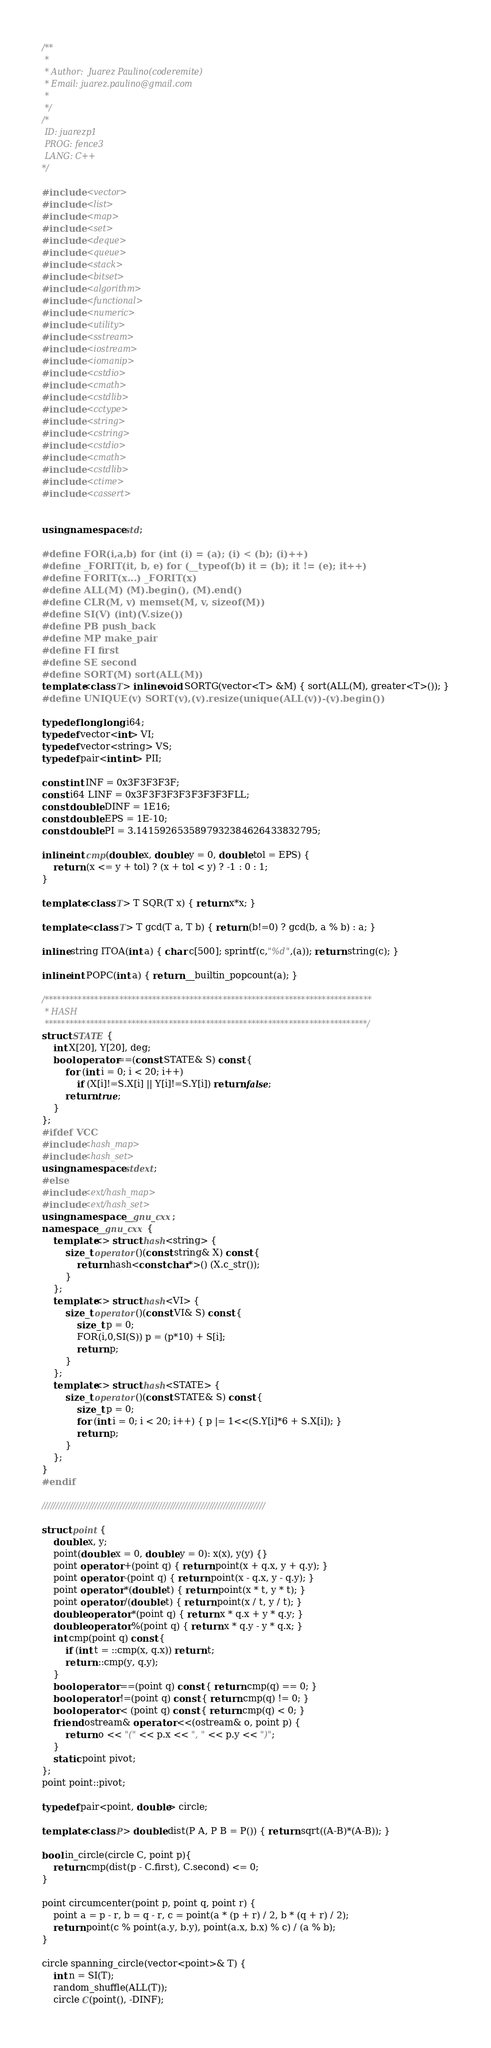Convert code to text. <code><loc_0><loc_0><loc_500><loc_500><_C++_>/**
 *
 * Author:  Juarez Paulino(coderemite)
 * Email: juarez.paulino@gmail.com
 *
 */
/*
 ID: juarezp1
 PROG: fence3
 LANG: C++
*/

#include <vector>
#include <list>
#include <map>
#include <set>
#include <deque>
#include <queue>
#include <stack>
#include <bitset>
#include <algorithm>
#include <functional>
#include <numeric>
#include <utility>
#include <sstream>
#include <iostream>
#include <iomanip>
#include <cstdio>
#include <cmath>
#include <cstdlib>
#include <cctype>
#include <string>
#include <cstring>
#include <cstdio>
#include <cmath>
#include <cstdlib>
#include <ctime>
#include <cassert>


using namespace std;

#define FOR(i,a,b) for (int (i) = (a); (i) < (b); (i)++)
#define _FORIT(it, b, e) for (__typeof(b) it = (b); it != (e); it++)
#define FORIT(x...) _FORIT(x)
#define ALL(M) (M).begin(), (M).end()
#define CLR(M, v) memset(M, v, sizeof(M))
#define SI(V) (int)(V.size())
#define PB push_back
#define MP make_pair
#define FI first
#define SE second
#define SORT(M) sort(ALL(M))
template<class T> inline void SORTG(vector<T> &M) { sort(ALL(M), greater<T>()); }
#define UNIQUE(v) SORT(v),(v).resize(unique(ALL(v))-(v).begin())

typedef long long i64;
typedef vector<int> VI;
typedef vector<string> VS;
typedef pair<int,int> PII;

const int INF = 0x3F3F3F3F;
const i64 LINF = 0x3F3F3F3F3F3F3F3FLL;
const double DINF = 1E16;
const double EPS = 1E-10;
const double PI = 3.1415926535897932384626433832795;

inline int cmp(double x, double y = 0, double tol = EPS) {
    return (x <= y + tol) ? (x + tol < y) ? -1 : 0 : 1;
}

template<class T> T SQR(T x) { return x*x; }

template <class T> T gcd(T a, T b) { return (b!=0) ? gcd(b, a % b) : a; }

inline string ITOA(int a) { char c[500]; sprintf(c,"%d",(a)); return string(c); }

inline int POPC(int a) { return __builtin_popcount(a); }

/*******************************************************************************
 * HASH
 ******************************************************************************/
struct STATE {
    int X[20], Y[20], deg;
    bool operator==(const STATE& S) const {
        for (int i = 0; i < 20; i++)
            if (X[i]!=S.X[i] || Y[i]!=S.Y[i]) return false;
        return true;
    }
};
#ifdef VCC
#include<hash_map>
#include<hash_set>
using namespace stdext;
#else
#include<ext/hash_map>
#include<ext/hash_set>
using namespace __gnu_cxx;
namespace __gnu_cxx {
	template<> struct hash<string> {
		size_t operator()(const string& X) const {
			return hash<const char*>() (X.c_str());
		}
	};
    template<> struct hash<VI> {
		size_t operator()(const VI& S) const {
            size_t p = 0;
            FOR(i,0,SI(S)) p = (p*10) + S[i];
            return p;
		}
	};
	template<> struct hash<STATE> {
		size_t operator()(const STATE& S) const {
            size_t p = 0;
            for (int i = 0; i < 20; i++) { p |= 1<<(S.Y[i]*6 + S.X[i]); }
            return p;
		}
	};
}
#endif

////////////////////////////////////////////////////////////////////////////////

struct point {
    double x, y;
    point(double x = 0, double y = 0): x(x), y(y) {}
    point operator +(point q) { return point(x + q.x, y + q.y); }
    point operator -(point q) { return point(x - q.x, y - q.y); }
    point operator *(double t) { return point(x * t, y * t); }
    point operator /(double t) { return point(x / t, y / t); }
    double operator *(point q) { return x * q.x + y * q.y; }
    double operator %(point q) { return x * q.y - y * q.x; }
    int cmp(point q) const {
        if (int t = ::cmp(x, q.x)) return t;
        return ::cmp(y, q.y);
    }
    bool operator ==(point q) const { return cmp(q) == 0; }
    bool operator !=(point q) const { return cmp(q) != 0; }
    bool operator < (point q) const { return cmp(q) < 0; }
    friend ostream& operator <<(ostream& o, point p) {
        return o << "(" << p.x << ", " << p.y << ")";
    }
    static point pivot;
};
point point::pivot;

typedef pair<point, double> circle;

template<class P> double dist(P A, P B = P()) { return sqrt((A-B)*(A-B)); }

bool in_circle(circle C, point p){
    return cmp(dist(p - C.first), C.second) <= 0;
}

point circumcenter(point p, point q, point r) {
    point a = p - r, b = q - r, c = point(a * (p + r) / 2, b * (q + r) / 2);
    return point(c % point(a.y, b.y), point(a.x, b.x) % c) / (a % b);
}

circle spanning_circle(vector<point>& T) {
    int n = SI(T);
    random_shuffle(ALL(T));
    circle C(point(), -DINF);</code> 